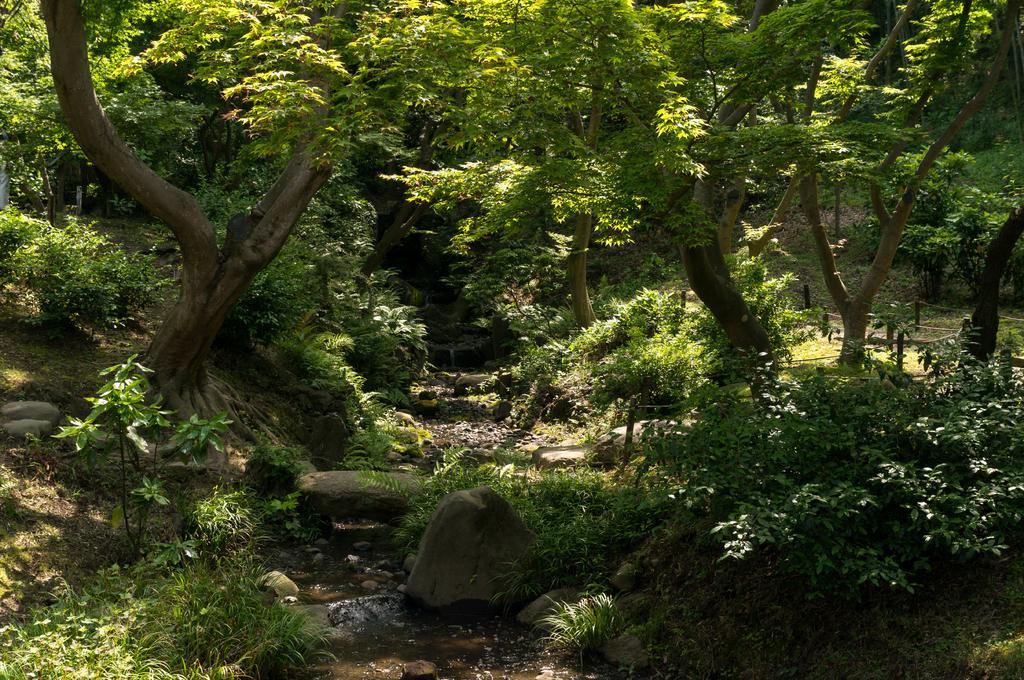Could you give a brief overview of what you see in this image? This image looks like it has been taken in a forest, it contains trees, plants and rocks. 